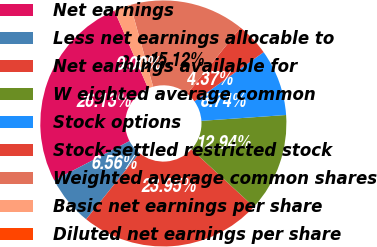Convert chart. <chart><loc_0><loc_0><loc_500><loc_500><pie_chart><fcel>Net earnings<fcel>Less net earnings allocable to<fcel>Net earnings available for<fcel>W eighted average common<fcel>Stock options<fcel>Stock-settled restricted stock<fcel>Weighted average common shares<fcel>Basic net earnings per share<fcel>Diluted net earnings per share<nl><fcel>26.13%<fcel>6.56%<fcel>23.95%<fcel>12.94%<fcel>8.74%<fcel>4.37%<fcel>15.12%<fcel>2.19%<fcel>0.0%<nl></chart> 